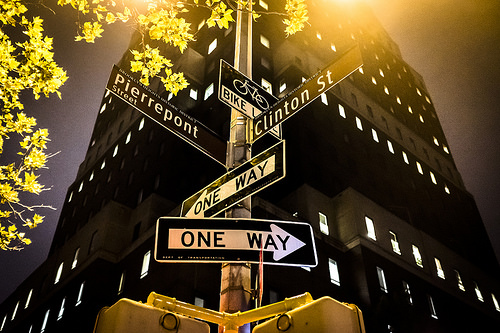<image>
Is there a sign on the building? No. The sign is not positioned on the building. They may be near each other, but the sign is not supported by or resting on top of the building. 